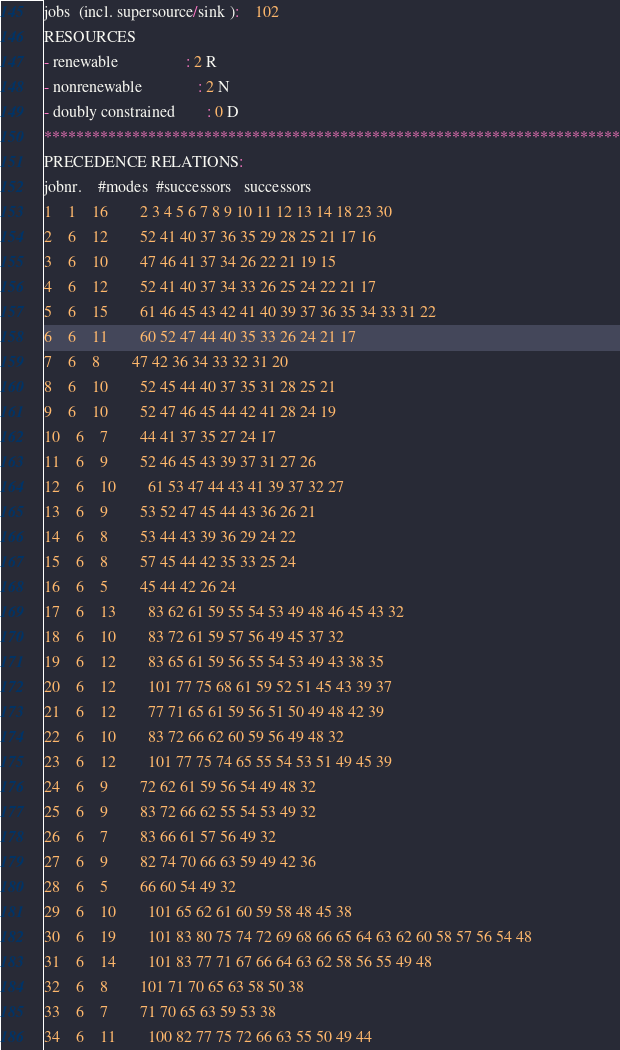<code> <loc_0><loc_0><loc_500><loc_500><_ObjectiveC_>jobs  (incl. supersource/sink ):	102
RESOURCES
- renewable                 : 2 R
- nonrenewable              : 2 N
- doubly constrained        : 0 D
************************************************************************
PRECEDENCE RELATIONS:
jobnr.    #modes  #successors   successors
1	1	16		2 3 4 5 6 7 8 9 10 11 12 13 14 18 23 30 
2	6	12		52 41 40 37 36 35 29 28 25 21 17 16 
3	6	10		47 46 41 37 34 26 22 21 19 15 
4	6	12		52 41 40 37 34 33 26 25 24 22 21 17 
5	6	15		61 46 45 43 42 41 40 39 37 36 35 34 33 31 22 
6	6	11		60 52 47 44 40 35 33 26 24 21 17 
7	6	8		47 42 36 34 33 32 31 20 
8	6	10		52 45 44 40 37 35 31 28 25 21 
9	6	10		52 47 46 45 44 42 41 28 24 19 
10	6	7		44 41 37 35 27 24 17 
11	6	9		52 46 45 43 39 37 31 27 26 
12	6	10		61 53 47 44 43 41 39 37 32 27 
13	6	9		53 52 47 45 44 43 36 26 21 
14	6	8		53 44 43 39 36 29 24 22 
15	6	8		57 45 44 42 35 33 25 24 
16	6	5		45 44 42 26 24 
17	6	13		83 62 61 59 55 54 53 49 48 46 45 43 32 
18	6	10		83 72 61 59 57 56 49 45 37 32 
19	6	12		83 65 61 59 56 55 54 53 49 43 38 35 
20	6	12		101 77 75 68 61 59 52 51 45 43 39 37 
21	6	12		77 71 65 61 59 56 51 50 49 48 42 39 
22	6	10		83 72 66 62 60 59 56 49 48 32 
23	6	12		101 77 75 74 65 55 54 53 51 49 45 39 
24	6	9		72 62 61 59 56 54 49 48 32 
25	6	9		83 72 66 62 55 54 53 49 32 
26	6	7		83 66 61 57 56 49 32 
27	6	9		82 74 70 66 63 59 49 42 36 
28	6	5		66 60 54 49 32 
29	6	10		101 65 62 61 60 59 58 48 45 38 
30	6	19		101 83 80 75 74 72 69 68 66 65 64 63 62 60 58 57 56 54 48 
31	6	14		101 83 77 71 67 66 64 63 62 58 56 55 49 48 
32	6	8		101 71 70 65 63 58 50 38 
33	6	7		71 70 65 63 59 53 38 
34	6	11		100 82 77 75 72 66 63 55 50 49 44 </code> 